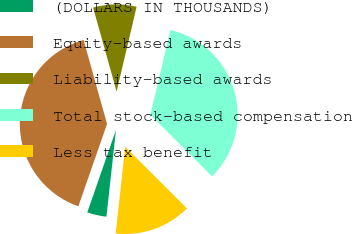Convert chart. <chart><loc_0><loc_0><loc_500><loc_500><pie_chart><fcel>(DOLLARS IN THOUSANDS)<fcel>Equity-based awards<fcel>Liability-based awards<fcel>Total stock-based compensation<fcel>Less tax benefit<nl><fcel>3.59%<fcel>40.32%<fcel>8.03%<fcel>33.79%<fcel>14.27%<nl></chart> 